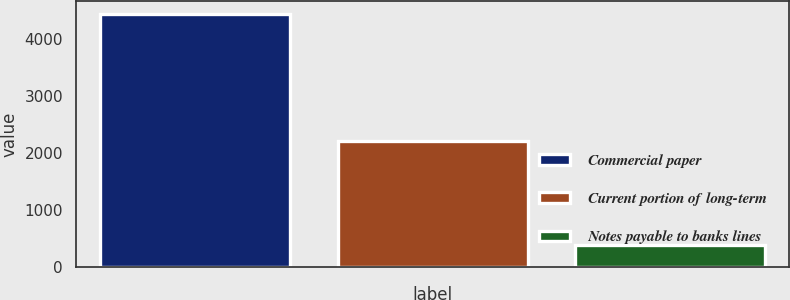Convert chart to OTSL. <chart><loc_0><loc_0><loc_500><loc_500><bar_chart><fcel>Commercial paper<fcel>Current portion of long-term<fcel>Notes payable to banks lines<nl><fcel>4432<fcel>2216<fcel>398<nl></chart> 